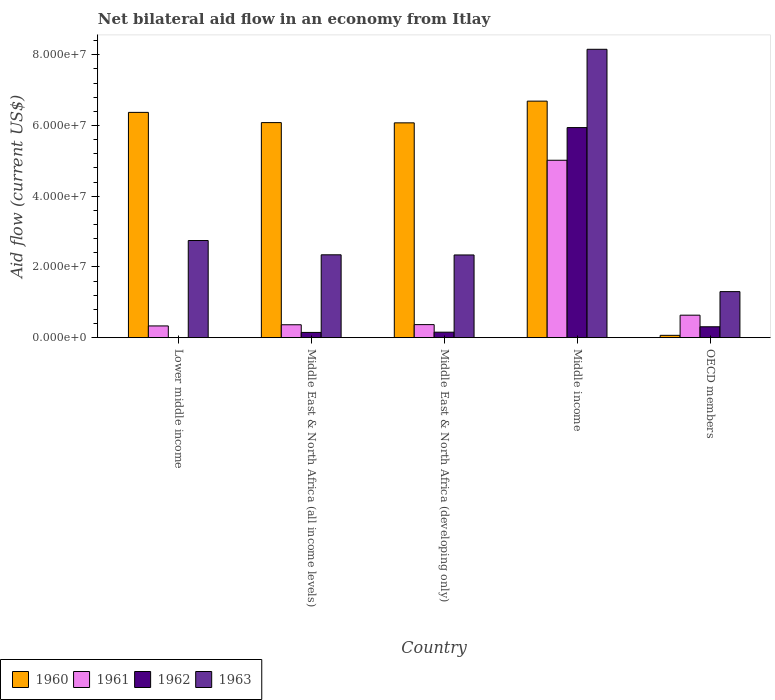How many different coloured bars are there?
Provide a short and direct response. 4. How many groups of bars are there?
Ensure brevity in your answer.  5. How many bars are there on the 3rd tick from the right?
Provide a short and direct response. 4. What is the label of the 1st group of bars from the left?
Ensure brevity in your answer.  Lower middle income. What is the net bilateral aid flow in 1960 in Middle East & North Africa (all income levels)?
Ensure brevity in your answer.  6.08e+07. Across all countries, what is the maximum net bilateral aid flow in 1960?
Your response must be concise. 6.69e+07. What is the total net bilateral aid flow in 1961 in the graph?
Your response must be concise. 6.72e+07. What is the difference between the net bilateral aid flow in 1963 in Lower middle income and that in Middle East & North Africa (all income levels)?
Provide a succinct answer. 4.04e+06. What is the difference between the net bilateral aid flow in 1961 in Middle income and the net bilateral aid flow in 1960 in OECD members?
Make the answer very short. 4.95e+07. What is the average net bilateral aid flow in 1963 per country?
Keep it short and to the point. 3.38e+07. What is the difference between the net bilateral aid flow of/in 1963 and net bilateral aid flow of/in 1960 in Middle income?
Keep it short and to the point. 1.47e+07. What is the ratio of the net bilateral aid flow in 1963 in Lower middle income to that in Middle East & North Africa (all income levels)?
Ensure brevity in your answer.  1.17. Is the net bilateral aid flow in 1963 in Middle income less than that in OECD members?
Give a very brief answer. No. Is the difference between the net bilateral aid flow in 1963 in Lower middle income and OECD members greater than the difference between the net bilateral aid flow in 1960 in Lower middle income and OECD members?
Offer a very short reply. No. What is the difference between the highest and the second highest net bilateral aid flow in 1960?
Give a very brief answer. 3.18e+06. What is the difference between the highest and the lowest net bilateral aid flow in 1960?
Give a very brief answer. 6.62e+07. Is the sum of the net bilateral aid flow in 1963 in Middle income and OECD members greater than the maximum net bilateral aid flow in 1960 across all countries?
Your answer should be compact. Yes. Is it the case that in every country, the sum of the net bilateral aid flow in 1962 and net bilateral aid flow in 1963 is greater than the net bilateral aid flow in 1961?
Provide a succinct answer. Yes. How many bars are there?
Offer a terse response. 19. What is the difference between two consecutive major ticks on the Y-axis?
Your answer should be very brief. 2.00e+07. Are the values on the major ticks of Y-axis written in scientific E-notation?
Provide a short and direct response. Yes. Does the graph contain grids?
Your response must be concise. No. Where does the legend appear in the graph?
Provide a short and direct response. Bottom left. What is the title of the graph?
Provide a short and direct response. Net bilateral aid flow in an economy from Itlay. What is the label or title of the X-axis?
Your response must be concise. Country. What is the label or title of the Y-axis?
Offer a terse response. Aid flow (current US$). What is the Aid flow (current US$) in 1960 in Lower middle income?
Provide a short and direct response. 6.37e+07. What is the Aid flow (current US$) of 1961 in Lower middle income?
Your answer should be compact. 3.32e+06. What is the Aid flow (current US$) in 1962 in Lower middle income?
Ensure brevity in your answer.  0. What is the Aid flow (current US$) in 1963 in Lower middle income?
Your answer should be very brief. 2.75e+07. What is the Aid flow (current US$) of 1960 in Middle East & North Africa (all income levels)?
Your answer should be very brief. 6.08e+07. What is the Aid flow (current US$) of 1961 in Middle East & North Africa (all income levels)?
Keep it short and to the point. 3.65e+06. What is the Aid flow (current US$) in 1962 in Middle East & North Africa (all income levels)?
Offer a terse response. 1.48e+06. What is the Aid flow (current US$) in 1963 in Middle East & North Africa (all income levels)?
Make the answer very short. 2.34e+07. What is the Aid flow (current US$) in 1960 in Middle East & North Africa (developing only)?
Provide a short and direct response. 6.08e+07. What is the Aid flow (current US$) of 1961 in Middle East & North Africa (developing only)?
Offer a very short reply. 3.69e+06. What is the Aid flow (current US$) of 1962 in Middle East & North Africa (developing only)?
Offer a very short reply. 1.55e+06. What is the Aid flow (current US$) of 1963 in Middle East & North Africa (developing only)?
Offer a very short reply. 2.34e+07. What is the Aid flow (current US$) in 1960 in Middle income?
Your response must be concise. 6.69e+07. What is the Aid flow (current US$) of 1961 in Middle income?
Give a very brief answer. 5.02e+07. What is the Aid flow (current US$) of 1962 in Middle income?
Ensure brevity in your answer.  5.94e+07. What is the Aid flow (current US$) in 1963 in Middle income?
Provide a short and direct response. 8.16e+07. What is the Aid flow (current US$) in 1960 in OECD members?
Provide a short and direct response. 6.60e+05. What is the Aid flow (current US$) in 1961 in OECD members?
Offer a very short reply. 6.36e+06. What is the Aid flow (current US$) in 1962 in OECD members?
Your response must be concise. 3.08e+06. What is the Aid flow (current US$) in 1963 in OECD members?
Ensure brevity in your answer.  1.30e+07. Across all countries, what is the maximum Aid flow (current US$) in 1960?
Your response must be concise. 6.69e+07. Across all countries, what is the maximum Aid flow (current US$) in 1961?
Your answer should be very brief. 5.02e+07. Across all countries, what is the maximum Aid flow (current US$) in 1962?
Offer a terse response. 5.94e+07. Across all countries, what is the maximum Aid flow (current US$) in 1963?
Offer a very short reply. 8.16e+07. Across all countries, what is the minimum Aid flow (current US$) in 1960?
Give a very brief answer. 6.60e+05. Across all countries, what is the minimum Aid flow (current US$) in 1961?
Your response must be concise. 3.32e+06. Across all countries, what is the minimum Aid flow (current US$) in 1963?
Make the answer very short. 1.30e+07. What is the total Aid flow (current US$) of 1960 in the graph?
Offer a very short reply. 2.53e+08. What is the total Aid flow (current US$) of 1961 in the graph?
Offer a very short reply. 6.72e+07. What is the total Aid flow (current US$) of 1962 in the graph?
Provide a short and direct response. 6.55e+07. What is the total Aid flow (current US$) in 1963 in the graph?
Your answer should be very brief. 1.69e+08. What is the difference between the Aid flow (current US$) of 1960 in Lower middle income and that in Middle East & North Africa (all income levels)?
Provide a short and direct response. 2.89e+06. What is the difference between the Aid flow (current US$) of 1961 in Lower middle income and that in Middle East & North Africa (all income levels)?
Your answer should be compact. -3.30e+05. What is the difference between the Aid flow (current US$) of 1963 in Lower middle income and that in Middle East & North Africa (all income levels)?
Provide a succinct answer. 4.04e+06. What is the difference between the Aid flow (current US$) in 1960 in Lower middle income and that in Middle East & North Africa (developing only)?
Give a very brief answer. 2.96e+06. What is the difference between the Aid flow (current US$) in 1961 in Lower middle income and that in Middle East & North Africa (developing only)?
Provide a short and direct response. -3.70e+05. What is the difference between the Aid flow (current US$) of 1963 in Lower middle income and that in Middle East & North Africa (developing only)?
Your answer should be compact. 4.08e+06. What is the difference between the Aid flow (current US$) in 1960 in Lower middle income and that in Middle income?
Provide a short and direct response. -3.18e+06. What is the difference between the Aid flow (current US$) in 1961 in Lower middle income and that in Middle income?
Provide a short and direct response. -4.68e+07. What is the difference between the Aid flow (current US$) of 1963 in Lower middle income and that in Middle income?
Give a very brief answer. -5.41e+07. What is the difference between the Aid flow (current US$) of 1960 in Lower middle income and that in OECD members?
Make the answer very short. 6.30e+07. What is the difference between the Aid flow (current US$) in 1961 in Lower middle income and that in OECD members?
Your answer should be compact. -3.04e+06. What is the difference between the Aid flow (current US$) of 1963 in Lower middle income and that in OECD members?
Keep it short and to the point. 1.44e+07. What is the difference between the Aid flow (current US$) of 1960 in Middle East & North Africa (all income levels) and that in Middle East & North Africa (developing only)?
Provide a succinct answer. 7.00e+04. What is the difference between the Aid flow (current US$) in 1961 in Middle East & North Africa (all income levels) and that in Middle East & North Africa (developing only)?
Ensure brevity in your answer.  -4.00e+04. What is the difference between the Aid flow (current US$) in 1963 in Middle East & North Africa (all income levels) and that in Middle East & North Africa (developing only)?
Your answer should be compact. 4.00e+04. What is the difference between the Aid flow (current US$) in 1960 in Middle East & North Africa (all income levels) and that in Middle income?
Provide a short and direct response. -6.07e+06. What is the difference between the Aid flow (current US$) of 1961 in Middle East & North Africa (all income levels) and that in Middle income?
Your answer should be very brief. -4.65e+07. What is the difference between the Aid flow (current US$) of 1962 in Middle East & North Africa (all income levels) and that in Middle income?
Keep it short and to the point. -5.79e+07. What is the difference between the Aid flow (current US$) of 1963 in Middle East & North Africa (all income levels) and that in Middle income?
Offer a very short reply. -5.81e+07. What is the difference between the Aid flow (current US$) in 1960 in Middle East & North Africa (all income levels) and that in OECD members?
Provide a succinct answer. 6.02e+07. What is the difference between the Aid flow (current US$) of 1961 in Middle East & North Africa (all income levels) and that in OECD members?
Provide a succinct answer. -2.71e+06. What is the difference between the Aid flow (current US$) of 1962 in Middle East & North Africa (all income levels) and that in OECD members?
Keep it short and to the point. -1.60e+06. What is the difference between the Aid flow (current US$) in 1963 in Middle East & North Africa (all income levels) and that in OECD members?
Keep it short and to the point. 1.04e+07. What is the difference between the Aid flow (current US$) in 1960 in Middle East & North Africa (developing only) and that in Middle income?
Make the answer very short. -6.14e+06. What is the difference between the Aid flow (current US$) of 1961 in Middle East & North Africa (developing only) and that in Middle income?
Your answer should be compact. -4.65e+07. What is the difference between the Aid flow (current US$) of 1962 in Middle East & North Africa (developing only) and that in Middle income?
Your answer should be compact. -5.79e+07. What is the difference between the Aid flow (current US$) in 1963 in Middle East & North Africa (developing only) and that in Middle income?
Make the answer very short. -5.82e+07. What is the difference between the Aid flow (current US$) in 1960 in Middle East & North Africa (developing only) and that in OECD members?
Offer a very short reply. 6.01e+07. What is the difference between the Aid flow (current US$) in 1961 in Middle East & North Africa (developing only) and that in OECD members?
Provide a succinct answer. -2.67e+06. What is the difference between the Aid flow (current US$) of 1962 in Middle East & North Africa (developing only) and that in OECD members?
Provide a succinct answer. -1.53e+06. What is the difference between the Aid flow (current US$) in 1963 in Middle East & North Africa (developing only) and that in OECD members?
Ensure brevity in your answer.  1.04e+07. What is the difference between the Aid flow (current US$) of 1960 in Middle income and that in OECD members?
Offer a terse response. 6.62e+07. What is the difference between the Aid flow (current US$) of 1961 in Middle income and that in OECD members?
Make the answer very short. 4.38e+07. What is the difference between the Aid flow (current US$) in 1962 in Middle income and that in OECD members?
Your answer should be very brief. 5.63e+07. What is the difference between the Aid flow (current US$) in 1963 in Middle income and that in OECD members?
Provide a succinct answer. 6.85e+07. What is the difference between the Aid flow (current US$) in 1960 in Lower middle income and the Aid flow (current US$) in 1961 in Middle East & North Africa (all income levels)?
Provide a succinct answer. 6.01e+07. What is the difference between the Aid flow (current US$) of 1960 in Lower middle income and the Aid flow (current US$) of 1962 in Middle East & North Africa (all income levels)?
Keep it short and to the point. 6.22e+07. What is the difference between the Aid flow (current US$) of 1960 in Lower middle income and the Aid flow (current US$) of 1963 in Middle East & North Africa (all income levels)?
Provide a short and direct response. 4.03e+07. What is the difference between the Aid flow (current US$) of 1961 in Lower middle income and the Aid flow (current US$) of 1962 in Middle East & North Africa (all income levels)?
Your answer should be compact. 1.84e+06. What is the difference between the Aid flow (current US$) of 1961 in Lower middle income and the Aid flow (current US$) of 1963 in Middle East & North Africa (all income levels)?
Your response must be concise. -2.01e+07. What is the difference between the Aid flow (current US$) in 1960 in Lower middle income and the Aid flow (current US$) in 1961 in Middle East & North Africa (developing only)?
Keep it short and to the point. 6.00e+07. What is the difference between the Aid flow (current US$) in 1960 in Lower middle income and the Aid flow (current US$) in 1962 in Middle East & North Africa (developing only)?
Your response must be concise. 6.22e+07. What is the difference between the Aid flow (current US$) of 1960 in Lower middle income and the Aid flow (current US$) of 1963 in Middle East & North Africa (developing only)?
Provide a short and direct response. 4.03e+07. What is the difference between the Aid flow (current US$) of 1961 in Lower middle income and the Aid flow (current US$) of 1962 in Middle East & North Africa (developing only)?
Provide a short and direct response. 1.77e+06. What is the difference between the Aid flow (current US$) in 1961 in Lower middle income and the Aid flow (current US$) in 1963 in Middle East & North Africa (developing only)?
Your response must be concise. -2.01e+07. What is the difference between the Aid flow (current US$) in 1960 in Lower middle income and the Aid flow (current US$) in 1961 in Middle income?
Your response must be concise. 1.35e+07. What is the difference between the Aid flow (current US$) of 1960 in Lower middle income and the Aid flow (current US$) of 1962 in Middle income?
Provide a short and direct response. 4.30e+06. What is the difference between the Aid flow (current US$) of 1960 in Lower middle income and the Aid flow (current US$) of 1963 in Middle income?
Keep it short and to the point. -1.78e+07. What is the difference between the Aid flow (current US$) of 1961 in Lower middle income and the Aid flow (current US$) of 1962 in Middle income?
Keep it short and to the point. -5.61e+07. What is the difference between the Aid flow (current US$) in 1961 in Lower middle income and the Aid flow (current US$) in 1963 in Middle income?
Your answer should be compact. -7.82e+07. What is the difference between the Aid flow (current US$) in 1960 in Lower middle income and the Aid flow (current US$) in 1961 in OECD members?
Provide a short and direct response. 5.74e+07. What is the difference between the Aid flow (current US$) of 1960 in Lower middle income and the Aid flow (current US$) of 1962 in OECD members?
Provide a succinct answer. 6.06e+07. What is the difference between the Aid flow (current US$) in 1960 in Lower middle income and the Aid flow (current US$) in 1963 in OECD members?
Your answer should be compact. 5.07e+07. What is the difference between the Aid flow (current US$) of 1961 in Lower middle income and the Aid flow (current US$) of 1963 in OECD members?
Keep it short and to the point. -9.70e+06. What is the difference between the Aid flow (current US$) of 1960 in Middle East & North Africa (all income levels) and the Aid flow (current US$) of 1961 in Middle East & North Africa (developing only)?
Your answer should be very brief. 5.71e+07. What is the difference between the Aid flow (current US$) of 1960 in Middle East & North Africa (all income levels) and the Aid flow (current US$) of 1962 in Middle East & North Africa (developing only)?
Offer a terse response. 5.93e+07. What is the difference between the Aid flow (current US$) of 1960 in Middle East & North Africa (all income levels) and the Aid flow (current US$) of 1963 in Middle East & North Africa (developing only)?
Ensure brevity in your answer.  3.74e+07. What is the difference between the Aid flow (current US$) in 1961 in Middle East & North Africa (all income levels) and the Aid flow (current US$) in 1962 in Middle East & North Africa (developing only)?
Give a very brief answer. 2.10e+06. What is the difference between the Aid flow (current US$) in 1961 in Middle East & North Africa (all income levels) and the Aid flow (current US$) in 1963 in Middle East & North Africa (developing only)?
Provide a succinct answer. -1.97e+07. What is the difference between the Aid flow (current US$) in 1962 in Middle East & North Africa (all income levels) and the Aid flow (current US$) in 1963 in Middle East & North Africa (developing only)?
Provide a short and direct response. -2.19e+07. What is the difference between the Aid flow (current US$) of 1960 in Middle East & North Africa (all income levels) and the Aid flow (current US$) of 1961 in Middle income?
Offer a terse response. 1.06e+07. What is the difference between the Aid flow (current US$) of 1960 in Middle East & North Africa (all income levels) and the Aid flow (current US$) of 1962 in Middle income?
Provide a short and direct response. 1.41e+06. What is the difference between the Aid flow (current US$) in 1960 in Middle East & North Africa (all income levels) and the Aid flow (current US$) in 1963 in Middle income?
Make the answer very short. -2.07e+07. What is the difference between the Aid flow (current US$) in 1961 in Middle East & North Africa (all income levels) and the Aid flow (current US$) in 1962 in Middle income?
Your answer should be very brief. -5.58e+07. What is the difference between the Aid flow (current US$) of 1961 in Middle East & North Africa (all income levels) and the Aid flow (current US$) of 1963 in Middle income?
Offer a terse response. -7.79e+07. What is the difference between the Aid flow (current US$) in 1962 in Middle East & North Africa (all income levels) and the Aid flow (current US$) in 1963 in Middle income?
Provide a succinct answer. -8.01e+07. What is the difference between the Aid flow (current US$) of 1960 in Middle East & North Africa (all income levels) and the Aid flow (current US$) of 1961 in OECD members?
Your response must be concise. 5.45e+07. What is the difference between the Aid flow (current US$) of 1960 in Middle East & North Africa (all income levels) and the Aid flow (current US$) of 1962 in OECD members?
Provide a succinct answer. 5.77e+07. What is the difference between the Aid flow (current US$) in 1960 in Middle East & North Africa (all income levels) and the Aid flow (current US$) in 1963 in OECD members?
Your answer should be compact. 4.78e+07. What is the difference between the Aid flow (current US$) of 1961 in Middle East & North Africa (all income levels) and the Aid flow (current US$) of 1962 in OECD members?
Offer a very short reply. 5.70e+05. What is the difference between the Aid flow (current US$) of 1961 in Middle East & North Africa (all income levels) and the Aid flow (current US$) of 1963 in OECD members?
Keep it short and to the point. -9.37e+06. What is the difference between the Aid flow (current US$) in 1962 in Middle East & North Africa (all income levels) and the Aid flow (current US$) in 1963 in OECD members?
Your answer should be compact. -1.15e+07. What is the difference between the Aid flow (current US$) of 1960 in Middle East & North Africa (developing only) and the Aid flow (current US$) of 1961 in Middle income?
Keep it short and to the point. 1.06e+07. What is the difference between the Aid flow (current US$) of 1960 in Middle East & North Africa (developing only) and the Aid flow (current US$) of 1962 in Middle income?
Your response must be concise. 1.34e+06. What is the difference between the Aid flow (current US$) of 1960 in Middle East & North Africa (developing only) and the Aid flow (current US$) of 1963 in Middle income?
Offer a very short reply. -2.08e+07. What is the difference between the Aid flow (current US$) of 1961 in Middle East & North Africa (developing only) and the Aid flow (current US$) of 1962 in Middle income?
Offer a terse response. -5.57e+07. What is the difference between the Aid flow (current US$) of 1961 in Middle East & North Africa (developing only) and the Aid flow (current US$) of 1963 in Middle income?
Your answer should be compact. -7.79e+07. What is the difference between the Aid flow (current US$) in 1962 in Middle East & North Africa (developing only) and the Aid flow (current US$) in 1963 in Middle income?
Make the answer very short. -8.00e+07. What is the difference between the Aid flow (current US$) of 1960 in Middle East & North Africa (developing only) and the Aid flow (current US$) of 1961 in OECD members?
Keep it short and to the point. 5.44e+07. What is the difference between the Aid flow (current US$) of 1960 in Middle East & North Africa (developing only) and the Aid flow (current US$) of 1962 in OECD members?
Ensure brevity in your answer.  5.77e+07. What is the difference between the Aid flow (current US$) of 1960 in Middle East & North Africa (developing only) and the Aid flow (current US$) of 1963 in OECD members?
Give a very brief answer. 4.77e+07. What is the difference between the Aid flow (current US$) in 1961 in Middle East & North Africa (developing only) and the Aid flow (current US$) in 1962 in OECD members?
Your response must be concise. 6.10e+05. What is the difference between the Aid flow (current US$) in 1961 in Middle East & North Africa (developing only) and the Aid flow (current US$) in 1963 in OECD members?
Your answer should be compact. -9.33e+06. What is the difference between the Aid flow (current US$) in 1962 in Middle East & North Africa (developing only) and the Aid flow (current US$) in 1963 in OECD members?
Your response must be concise. -1.15e+07. What is the difference between the Aid flow (current US$) of 1960 in Middle income and the Aid flow (current US$) of 1961 in OECD members?
Your response must be concise. 6.05e+07. What is the difference between the Aid flow (current US$) in 1960 in Middle income and the Aid flow (current US$) in 1962 in OECD members?
Your answer should be compact. 6.38e+07. What is the difference between the Aid flow (current US$) in 1960 in Middle income and the Aid flow (current US$) in 1963 in OECD members?
Keep it short and to the point. 5.39e+07. What is the difference between the Aid flow (current US$) of 1961 in Middle income and the Aid flow (current US$) of 1962 in OECD members?
Your response must be concise. 4.71e+07. What is the difference between the Aid flow (current US$) of 1961 in Middle income and the Aid flow (current US$) of 1963 in OECD members?
Provide a succinct answer. 3.72e+07. What is the difference between the Aid flow (current US$) in 1962 in Middle income and the Aid flow (current US$) in 1963 in OECD members?
Keep it short and to the point. 4.64e+07. What is the average Aid flow (current US$) in 1960 per country?
Provide a short and direct response. 5.06e+07. What is the average Aid flow (current US$) of 1961 per country?
Offer a terse response. 1.34e+07. What is the average Aid flow (current US$) of 1962 per country?
Keep it short and to the point. 1.31e+07. What is the average Aid flow (current US$) of 1963 per country?
Provide a short and direct response. 3.38e+07. What is the difference between the Aid flow (current US$) in 1960 and Aid flow (current US$) in 1961 in Lower middle income?
Make the answer very short. 6.04e+07. What is the difference between the Aid flow (current US$) of 1960 and Aid flow (current US$) of 1963 in Lower middle income?
Your answer should be very brief. 3.62e+07. What is the difference between the Aid flow (current US$) of 1961 and Aid flow (current US$) of 1963 in Lower middle income?
Your answer should be very brief. -2.42e+07. What is the difference between the Aid flow (current US$) in 1960 and Aid flow (current US$) in 1961 in Middle East & North Africa (all income levels)?
Give a very brief answer. 5.72e+07. What is the difference between the Aid flow (current US$) in 1960 and Aid flow (current US$) in 1962 in Middle East & North Africa (all income levels)?
Keep it short and to the point. 5.93e+07. What is the difference between the Aid flow (current US$) of 1960 and Aid flow (current US$) of 1963 in Middle East & North Africa (all income levels)?
Offer a terse response. 3.74e+07. What is the difference between the Aid flow (current US$) of 1961 and Aid flow (current US$) of 1962 in Middle East & North Africa (all income levels)?
Your answer should be very brief. 2.17e+06. What is the difference between the Aid flow (current US$) in 1961 and Aid flow (current US$) in 1963 in Middle East & North Africa (all income levels)?
Make the answer very short. -1.98e+07. What is the difference between the Aid flow (current US$) in 1962 and Aid flow (current US$) in 1963 in Middle East & North Africa (all income levels)?
Your answer should be very brief. -2.20e+07. What is the difference between the Aid flow (current US$) in 1960 and Aid flow (current US$) in 1961 in Middle East & North Africa (developing only)?
Ensure brevity in your answer.  5.71e+07. What is the difference between the Aid flow (current US$) in 1960 and Aid flow (current US$) in 1962 in Middle East & North Africa (developing only)?
Provide a succinct answer. 5.92e+07. What is the difference between the Aid flow (current US$) in 1960 and Aid flow (current US$) in 1963 in Middle East & North Africa (developing only)?
Ensure brevity in your answer.  3.74e+07. What is the difference between the Aid flow (current US$) in 1961 and Aid flow (current US$) in 1962 in Middle East & North Africa (developing only)?
Offer a terse response. 2.14e+06. What is the difference between the Aid flow (current US$) of 1961 and Aid flow (current US$) of 1963 in Middle East & North Africa (developing only)?
Offer a terse response. -1.97e+07. What is the difference between the Aid flow (current US$) of 1962 and Aid flow (current US$) of 1963 in Middle East & North Africa (developing only)?
Provide a short and direct response. -2.18e+07. What is the difference between the Aid flow (current US$) of 1960 and Aid flow (current US$) of 1961 in Middle income?
Ensure brevity in your answer.  1.67e+07. What is the difference between the Aid flow (current US$) of 1960 and Aid flow (current US$) of 1962 in Middle income?
Ensure brevity in your answer.  7.48e+06. What is the difference between the Aid flow (current US$) of 1960 and Aid flow (current US$) of 1963 in Middle income?
Your response must be concise. -1.47e+07. What is the difference between the Aid flow (current US$) of 1961 and Aid flow (current US$) of 1962 in Middle income?
Make the answer very short. -9.24e+06. What is the difference between the Aid flow (current US$) in 1961 and Aid flow (current US$) in 1963 in Middle income?
Provide a succinct answer. -3.14e+07. What is the difference between the Aid flow (current US$) of 1962 and Aid flow (current US$) of 1963 in Middle income?
Ensure brevity in your answer.  -2.21e+07. What is the difference between the Aid flow (current US$) of 1960 and Aid flow (current US$) of 1961 in OECD members?
Keep it short and to the point. -5.70e+06. What is the difference between the Aid flow (current US$) of 1960 and Aid flow (current US$) of 1962 in OECD members?
Offer a very short reply. -2.42e+06. What is the difference between the Aid flow (current US$) in 1960 and Aid flow (current US$) in 1963 in OECD members?
Provide a succinct answer. -1.24e+07. What is the difference between the Aid flow (current US$) of 1961 and Aid flow (current US$) of 1962 in OECD members?
Your response must be concise. 3.28e+06. What is the difference between the Aid flow (current US$) of 1961 and Aid flow (current US$) of 1963 in OECD members?
Your response must be concise. -6.66e+06. What is the difference between the Aid flow (current US$) of 1962 and Aid flow (current US$) of 1963 in OECD members?
Provide a succinct answer. -9.94e+06. What is the ratio of the Aid flow (current US$) of 1960 in Lower middle income to that in Middle East & North Africa (all income levels)?
Offer a very short reply. 1.05. What is the ratio of the Aid flow (current US$) in 1961 in Lower middle income to that in Middle East & North Africa (all income levels)?
Your answer should be compact. 0.91. What is the ratio of the Aid flow (current US$) of 1963 in Lower middle income to that in Middle East & North Africa (all income levels)?
Offer a very short reply. 1.17. What is the ratio of the Aid flow (current US$) in 1960 in Lower middle income to that in Middle East & North Africa (developing only)?
Ensure brevity in your answer.  1.05. What is the ratio of the Aid flow (current US$) in 1961 in Lower middle income to that in Middle East & North Africa (developing only)?
Make the answer very short. 0.9. What is the ratio of the Aid flow (current US$) of 1963 in Lower middle income to that in Middle East & North Africa (developing only)?
Keep it short and to the point. 1.17. What is the ratio of the Aid flow (current US$) in 1960 in Lower middle income to that in Middle income?
Keep it short and to the point. 0.95. What is the ratio of the Aid flow (current US$) of 1961 in Lower middle income to that in Middle income?
Your response must be concise. 0.07. What is the ratio of the Aid flow (current US$) of 1963 in Lower middle income to that in Middle income?
Ensure brevity in your answer.  0.34. What is the ratio of the Aid flow (current US$) in 1960 in Lower middle income to that in OECD members?
Your answer should be compact. 96.53. What is the ratio of the Aid flow (current US$) of 1961 in Lower middle income to that in OECD members?
Ensure brevity in your answer.  0.52. What is the ratio of the Aid flow (current US$) of 1963 in Lower middle income to that in OECD members?
Offer a terse response. 2.11. What is the ratio of the Aid flow (current US$) in 1962 in Middle East & North Africa (all income levels) to that in Middle East & North Africa (developing only)?
Offer a very short reply. 0.95. What is the ratio of the Aid flow (current US$) of 1963 in Middle East & North Africa (all income levels) to that in Middle East & North Africa (developing only)?
Ensure brevity in your answer.  1. What is the ratio of the Aid flow (current US$) of 1960 in Middle East & North Africa (all income levels) to that in Middle income?
Provide a short and direct response. 0.91. What is the ratio of the Aid flow (current US$) in 1961 in Middle East & North Africa (all income levels) to that in Middle income?
Provide a succinct answer. 0.07. What is the ratio of the Aid flow (current US$) in 1962 in Middle East & North Africa (all income levels) to that in Middle income?
Provide a short and direct response. 0.02. What is the ratio of the Aid flow (current US$) of 1963 in Middle East & North Africa (all income levels) to that in Middle income?
Make the answer very short. 0.29. What is the ratio of the Aid flow (current US$) in 1960 in Middle East & North Africa (all income levels) to that in OECD members?
Make the answer very short. 92.15. What is the ratio of the Aid flow (current US$) in 1961 in Middle East & North Africa (all income levels) to that in OECD members?
Make the answer very short. 0.57. What is the ratio of the Aid flow (current US$) of 1962 in Middle East & North Africa (all income levels) to that in OECD members?
Give a very brief answer. 0.48. What is the ratio of the Aid flow (current US$) in 1963 in Middle East & North Africa (all income levels) to that in OECD members?
Provide a short and direct response. 1.8. What is the ratio of the Aid flow (current US$) in 1960 in Middle East & North Africa (developing only) to that in Middle income?
Keep it short and to the point. 0.91. What is the ratio of the Aid flow (current US$) of 1961 in Middle East & North Africa (developing only) to that in Middle income?
Your answer should be compact. 0.07. What is the ratio of the Aid flow (current US$) of 1962 in Middle East & North Africa (developing only) to that in Middle income?
Your response must be concise. 0.03. What is the ratio of the Aid flow (current US$) in 1963 in Middle East & North Africa (developing only) to that in Middle income?
Make the answer very short. 0.29. What is the ratio of the Aid flow (current US$) of 1960 in Middle East & North Africa (developing only) to that in OECD members?
Your answer should be compact. 92.05. What is the ratio of the Aid flow (current US$) of 1961 in Middle East & North Africa (developing only) to that in OECD members?
Ensure brevity in your answer.  0.58. What is the ratio of the Aid flow (current US$) in 1962 in Middle East & North Africa (developing only) to that in OECD members?
Your response must be concise. 0.5. What is the ratio of the Aid flow (current US$) of 1963 in Middle East & North Africa (developing only) to that in OECD members?
Offer a terse response. 1.8. What is the ratio of the Aid flow (current US$) in 1960 in Middle income to that in OECD members?
Give a very brief answer. 101.35. What is the ratio of the Aid flow (current US$) of 1961 in Middle income to that in OECD members?
Provide a short and direct response. 7.89. What is the ratio of the Aid flow (current US$) of 1962 in Middle income to that in OECD members?
Your answer should be compact. 19.29. What is the ratio of the Aid flow (current US$) of 1963 in Middle income to that in OECD members?
Ensure brevity in your answer.  6.26. What is the difference between the highest and the second highest Aid flow (current US$) of 1960?
Provide a succinct answer. 3.18e+06. What is the difference between the highest and the second highest Aid flow (current US$) of 1961?
Your response must be concise. 4.38e+07. What is the difference between the highest and the second highest Aid flow (current US$) in 1962?
Your answer should be compact. 5.63e+07. What is the difference between the highest and the second highest Aid flow (current US$) in 1963?
Keep it short and to the point. 5.41e+07. What is the difference between the highest and the lowest Aid flow (current US$) of 1960?
Offer a terse response. 6.62e+07. What is the difference between the highest and the lowest Aid flow (current US$) in 1961?
Make the answer very short. 4.68e+07. What is the difference between the highest and the lowest Aid flow (current US$) in 1962?
Your response must be concise. 5.94e+07. What is the difference between the highest and the lowest Aid flow (current US$) in 1963?
Offer a terse response. 6.85e+07. 